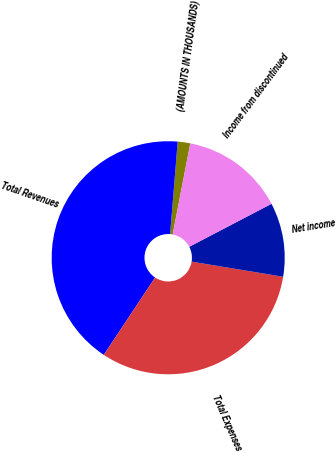<chart> <loc_0><loc_0><loc_500><loc_500><pie_chart><fcel>(AMOUNTS IN THOUSANDS)<fcel>Total Revenues<fcel>Total Expenses<fcel>Net income<fcel>Income from discontinued<nl><fcel>1.74%<fcel>41.98%<fcel>31.71%<fcel>10.27%<fcel>14.3%<nl></chart> 